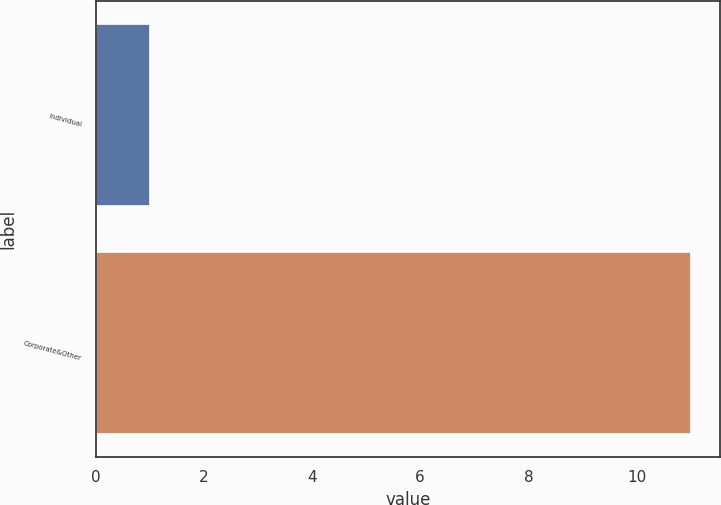Convert chart. <chart><loc_0><loc_0><loc_500><loc_500><bar_chart><fcel>Individual<fcel>Corporate&Other<nl><fcel>1<fcel>11<nl></chart> 